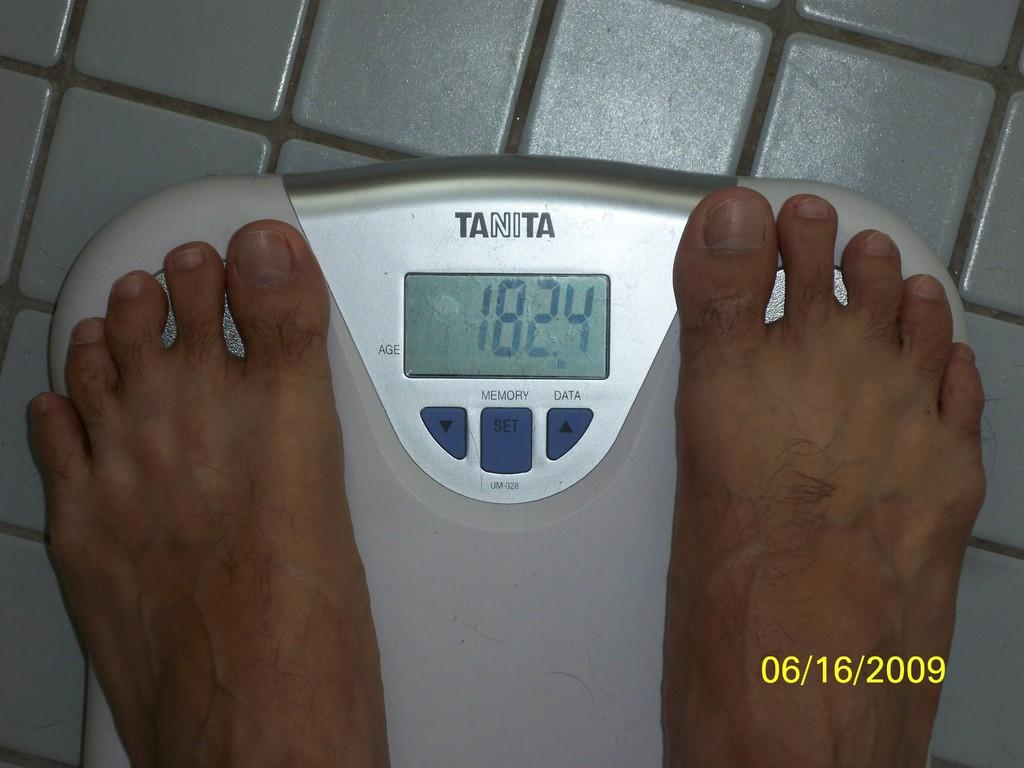<image>
Write a terse but informative summary of the picture. A Tanita scale displays someone's weight as 182.4 lbs. 